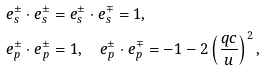<formula> <loc_0><loc_0><loc_500><loc_500>& e _ { s } ^ { \pm } \cdot e _ { s } ^ { \pm } = e _ { s } ^ { \pm } \cdot e _ { s } ^ { \mp } = 1 , \\ & e _ { p } ^ { \pm } \cdot e _ { p } ^ { \pm } = 1 , \quad e _ { p } ^ { \pm } \cdot e _ { p } ^ { \mp } = - 1 - 2 \left ( \frac { q c } { u } \right ) ^ { 2 } ,</formula> 